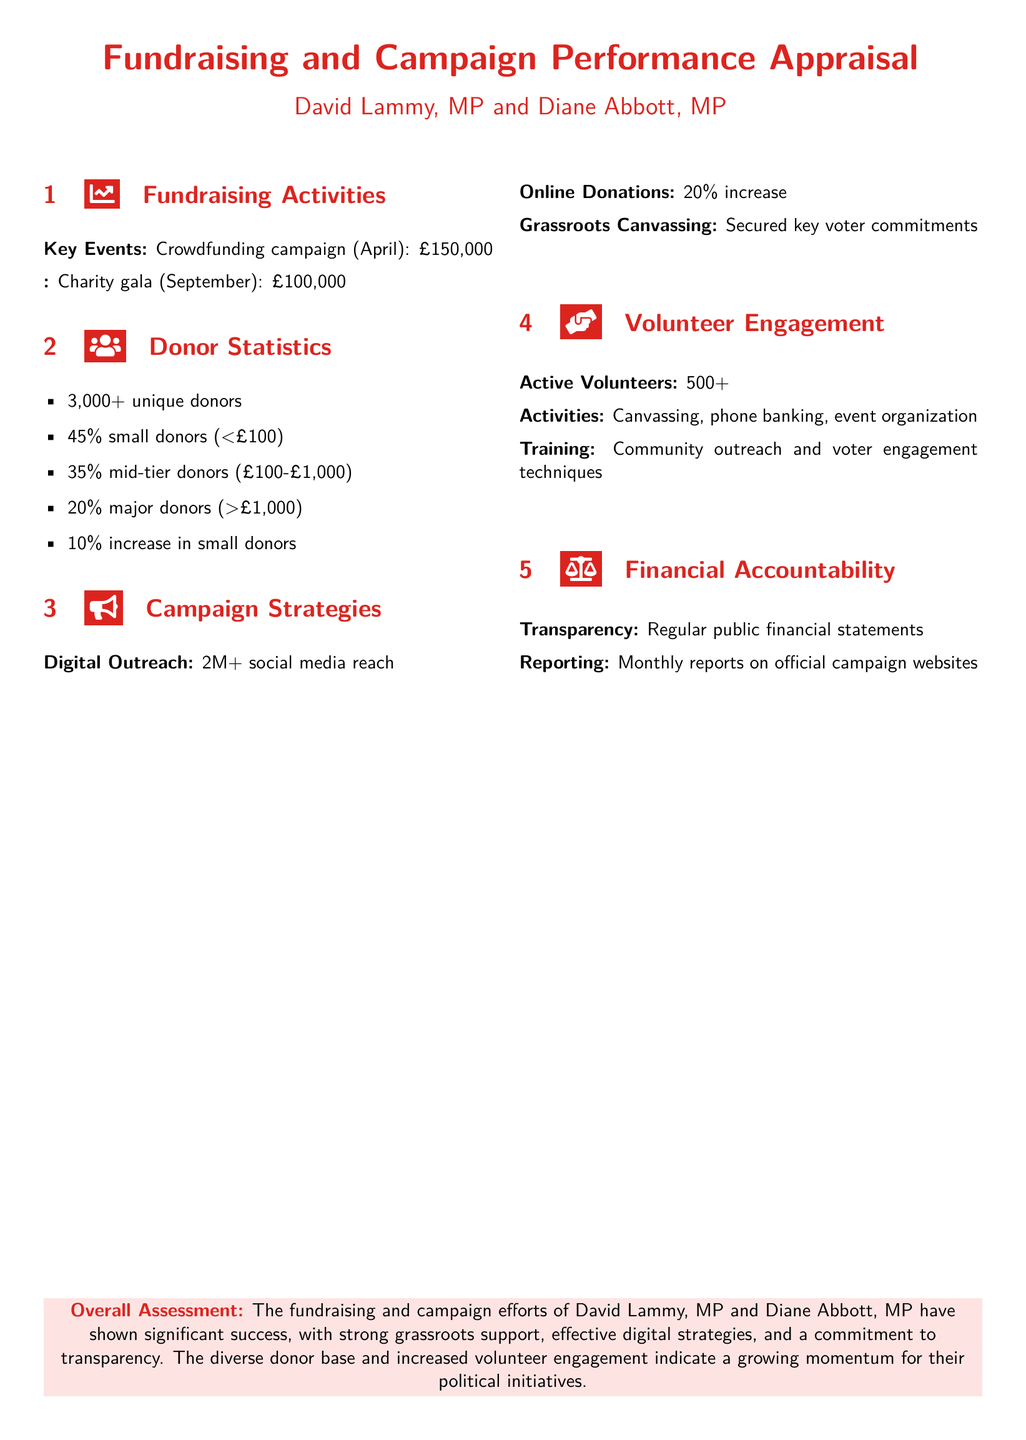What was the total raised in the crowdfunding campaign? The crowdfunding campaign raised £150,000 as stated in the document under fundraising activities.
Answer: £150,000 How many unique donors contributed to the campaign? The document mentions that there were over 3,000 unique donors involved in the campaign.
Answer: 3,000+ What percentage of donors were small donors? The document specifies that 45% of the donors were small donors, defined as those giving less than £100.
Answer: 45% What is the total financial transparency commitment made? The document states that there are regular public financial statements provided to ensure transparency.
Answer: Regular public financial statements What was the increase in online donations? The document indicates that there was a 20% increase in online donations as part of the campaign's effectiveness measures.
Answer: 20% What campaign strategy resulted in securing key voter commitments? The document mentions that grassroots canvassing was responsible for securing key voter commitments.
Answer: Grassroots Canvassing How many active volunteers are involved in the campaign? According to the document, there are over 500 active volunteers supporting the campaign activities.
Answer: 500+ What assessment is made about the fundraising and campaign efforts? The overall assessment in the document concludes that the fundraising and campaign efforts are described as showing significant success.
Answer: Significant success 